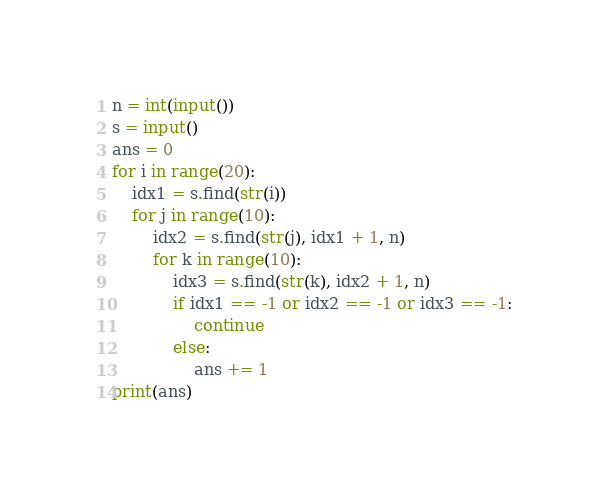<code> <loc_0><loc_0><loc_500><loc_500><_Python_>n = int(input())
s = input()
ans = 0
for i in range(20):
    idx1 = s.find(str(i))
    for j in range(10):
        idx2 = s.find(str(j), idx1 + 1, n)
        for k in range(10):
            idx3 = s.find(str(k), idx2 + 1, n)
            if idx1 == -1 or idx2 == -1 or idx3 == -1:
                continue
            else:
                ans += 1
print(ans)
</code> 